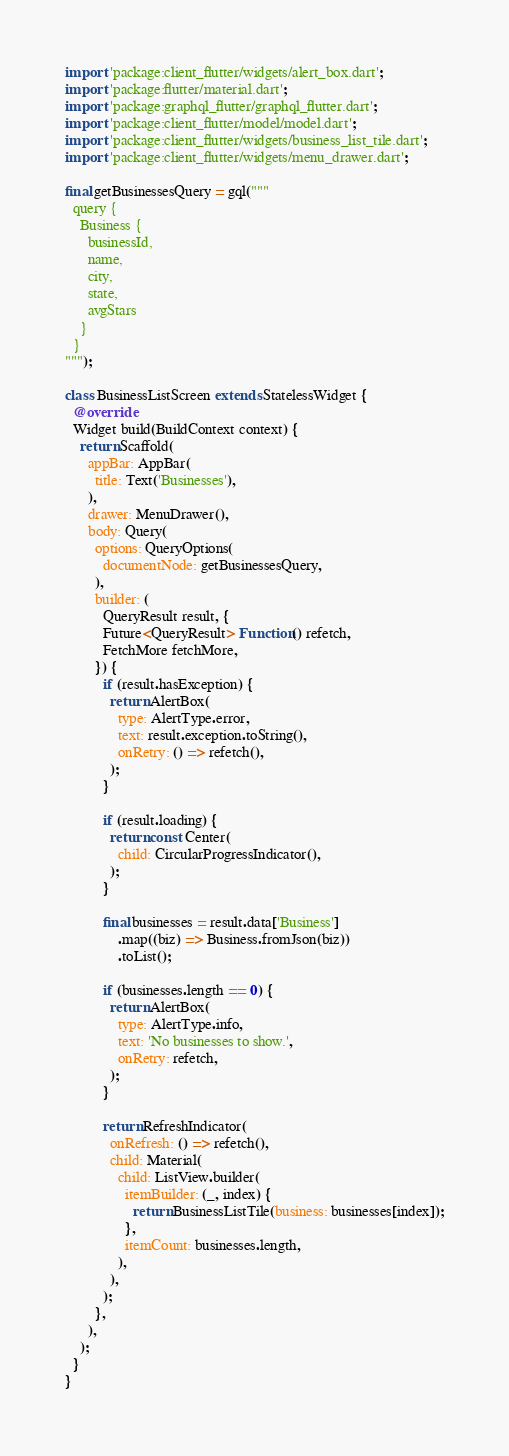<code> <loc_0><loc_0><loc_500><loc_500><_Dart_>import 'package:client_flutter/widgets/alert_box.dart';
import 'package:flutter/material.dart';
import 'package:graphql_flutter/graphql_flutter.dart';
import 'package:client_flutter/model/model.dart';
import 'package:client_flutter/widgets/business_list_tile.dart';
import 'package:client_flutter/widgets/menu_drawer.dart';

final getBusinessesQuery = gql("""
  query {
    Business {
      businessId,
      name,
      city,
      state,
      avgStars
    }
  }
""");

class BusinessListScreen extends StatelessWidget {
  @override
  Widget build(BuildContext context) {
    return Scaffold(
      appBar: AppBar(
        title: Text('Businesses'),
      ),
      drawer: MenuDrawer(),
      body: Query(
        options: QueryOptions(
          documentNode: getBusinessesQuery,
        ),
        builder: (
          QueryResult result, {
          Future<QueryResult> Function() refetch,
          FetchMore fetchMore,
        }) {
          if (result.hasException) {
            return AlertBox(
              type: AlertType.error,
              text: result.exception.toString(),
              onRetry: () => refetch(),
            );
          }

          if (result.loading) {
            return const Center(
              child: CircularProgressIndicator(),
            );
          }

          final businesses = result.data['Business']
              .map((biz) => Business.fromJson(biz))
              .toList();

          if (businesses.length == 0) {
            return AlertBox(
              type: AlertType.info,
              text: 'No businesses to show.',
              onRetry: refetch,
            );
          }

          return RefreshIndicator(
            onRefresh: () => refetch(),
            child: Material(
              child: ListView.builder(
                itemBuilder: (_, index) {
                  return BusinessListTile(business: businesses[index]);
                },
                itemCount: businesses.length,
              ),
            ),
          );
        },
      ),
    );
  }
}
</code> 